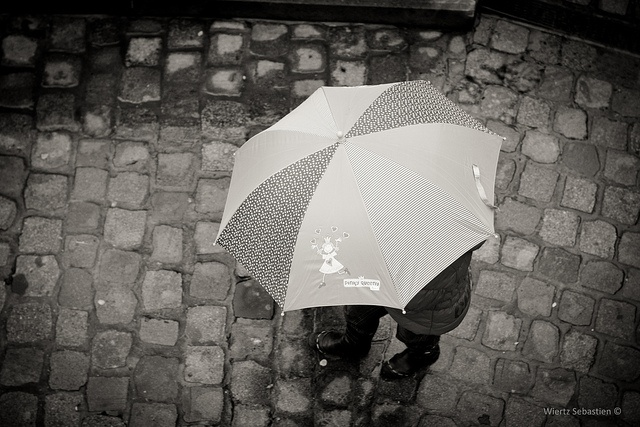Describe the objects in this image and their specific colors. I can see umbrella in black, lightgray, darkgray, and gray tones and people in black, gray, and darkgray tones in this image. 